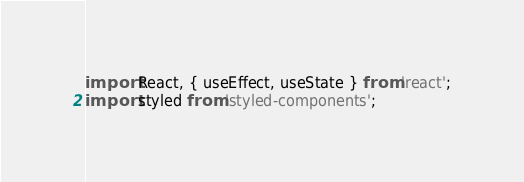<code> <loc_0><loc_0><loc_500><loc_500><_JavaScript_>import React, { useEffect, useState } from 'react';
import styled from 'styled-components';</code> 